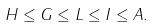Convert formula to latex. <formula><loc_0><loc_0><loc_500><loc_500>H \leq G \leq L \leq I \leq A .</formula> 